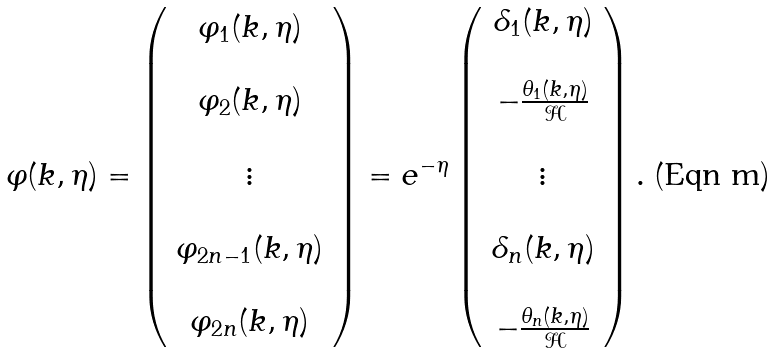<formula> <loc_0><loc_0><loc_500><loc_500>\varphi ( k , \eta ) = \left ( \begin{array} { c } \varphi _ { 1 } ( k , \eta ) \\ \\ \varphi _ { 2 } ( k , \eta ) \\ \\ \vdots \\ \\ \varphi _ { 2 n - 1 } ( k , \eta ) \\ \\ \varphi _ { 2 n } ( k , \eta ) \end{array} \right ) = e ^ { - \eta } \left ( \begin{array} { c } \delta _ { 1 } ( k , \eta ) \\ \\ - \frac { \theta _ { 1 } ( k , \eta ) } { \mathcal { H } } \\ \\ \vdots \\ \\ \delta _ { n } ( k , \eta ) \\ \\ - \frac { \theta _ { n } ( k , \eta ) } { \mathcal { H } } \end{array} \right ) .</formula> 